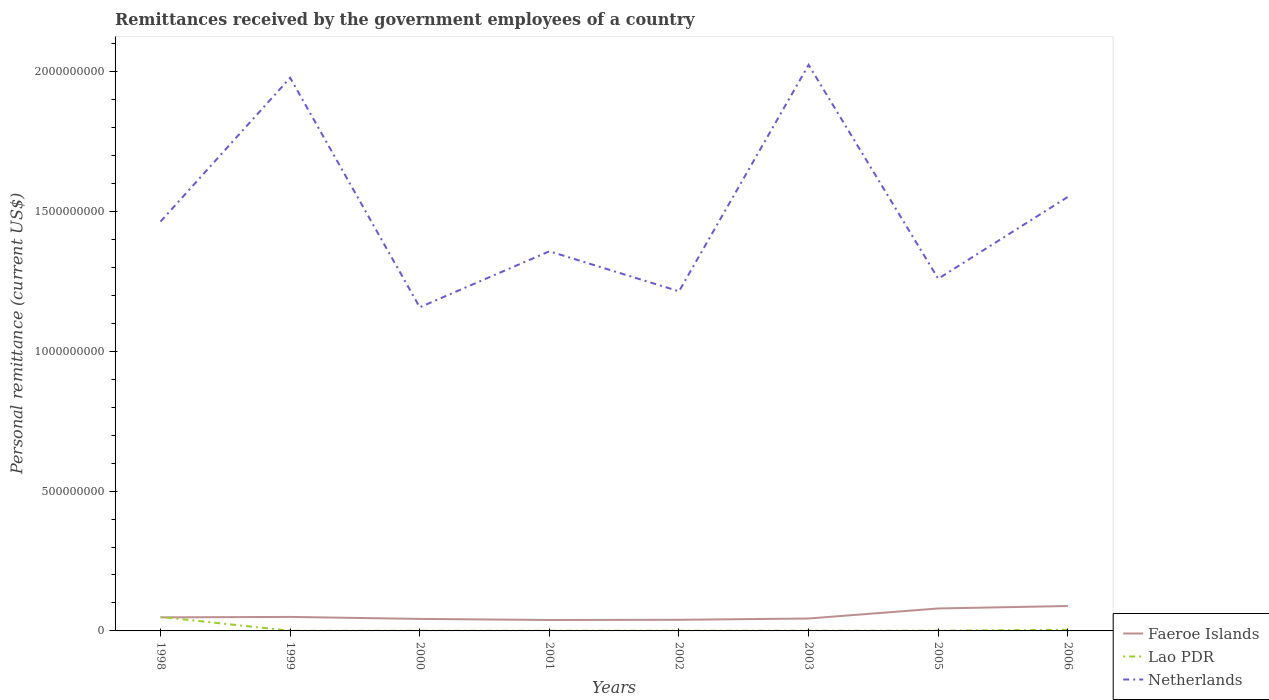How many different coloured lines are there?
Ensure brevity in your answer.  3. Is the number of lines equal to the number of legend labels?
Give a very brief answer. Yes. Across all years, what is the maximum remittances received by the government employees in Faeroe Islands?
Your answer should be compact. 3.90e+07. What is the total remittances received by the government employees in Netherlands in the graph?
Your response must be concise. -6.67e+08. What is the difference between the highest and the second highest remittances received by the government employees in Lao PDR?
Give a very brief answer. 4.94e+07. Is the remittances received by the government employees in Faeroe Islands strictly greater than the remittances received by the government employees in Netherlands over the years?
Offer a very short reply. Yes. Where does the legend appear in the graph?
Give a very brief answer. Bottom right. How many legend labels are there?
Provide a succinct answer. 3. How are the legend labels stacked?
Make the answer very short. Vertical. What is the title of the graph?
Provide a short and direct response. Remittances received by the government employees of a country. Does "Antigua and Barbuda" appear as one of the legend labels in the graph?
Offer a terse response. No. What is the label or title of the X-axis?
Make the answer very short. Years. What is the label or title of the Y-axis?
Your response must be concise. Personal remittance (current US$). What is the Personal remittance (current US$) in Faeroe Islands in 1998?
Your answer should be compact. 4.85e+07. What is the Personal remittance (current US$) in Lao PDR in 1998?
Make the answer very short. 5.00e+07. What is the Personal remittance (current US$) in Netherlands in 1998?
Your answer should be compact. 1.46e+09. What is the Personal remittance (current US$) in Faeroe Islands in 1999?
Give a very brief answer. 5.00e+07. What is the Personal remittance (current US$) of Lao PDR in 1999?
Your answer should be very brief. 6.00e+05. What is the Personal remittance (current US$) of Netherlands in 1999?
Offer a terse response. 1.98e+09. What is the Personal remittance (current US$) of Faeroe Islands in 2000?
Give a very brief answer. 4.30e+07. What is the Personal remittance (current US$) in Lao PDR in 2000?
Provide a succinct answer. 6.60e+05. What is the Personal remittance (current US$) of Netherlands in 2000?
Give a very brief answer. 1.16e+09. What is the Personal remittance (current US$) of Faeroe Islands in 2001?
Give a very brief answer. 3.90e+07. What is the Personal remittance (current US$) of Lao PDR in 2001?
Offer a very short reply. 6.95e+05. What is the Personal remittance (current US$) of Netherlands in 2001?
Offer a terse response. 1.36e+09. What is the Personal remittance (current US$) in Faeroe Islands in 2002?
Your response must be concise. 3.98e+07. What is the Personal remittance (current US$) in Lao PDR in 2002?
Ensure brevity in your answer.  7.29e+05. What is the Personal remittance (current US$) in Netherlands in 2002?
Your response must be concise. 1.21e+09. What is the Personal remittance (current US$) in Faeroe Islands in 2003?
Provide a succinct answer. 4.44e+07. What is the Personal remittance (current US$) in Lao PDR in 2003?
Give a very brief answer. 7.66e+05. What is the Personal remittance (current US$) in Netherlands in 2003?
Give a very brief answer. 2.02e+09. What is the Personal remittance (current US$) of Faeroe Islands in 2005?
Give a very brief answer. 8.03e+07. What is the Personal remittance (current US$) of Lao PDR in 2005?
Offer a very short reply. 8.30e+05. What is the Personal remittance (current US$) of Netherlands in 2005?
Provide a short and direct response. 1.26e+09. What is the Personal remittance (current US$) in Faeroe Islands in 2006?
Ensure brevity in your answer.  8.91e+07. What is the Personal remittance (current US$) of Lao PDR in 2006?
Your answer should be compact. 4.24e+06. What is the Personal remittance (current US$) of Netherlands in 2006?
Your response must be concise. 1.55e+09. Across all years, what is the maximum Personal remittance (current US$) in Faeroe Islands?
Make the answer very short. 8.91e+07. Across all years, what is the maximum Personal remittance (current US$) in Lao PDR?
Your answer should be very brief. 5.00e+07. Across all years, what is the maximum Personal remittance (current US$) in Netherlands?
Keep it short and to the point. 2.02e+09. Across all years, what is the minimum Personal remittance (current US$) of Faeroe Islands?
Your response must be concise. 3.90e+07. Across all years, what is the minimum Personal remittance (current US$) in Lao PDR?
Your answer should be compact. 6.00e+05. Across all years, what is the minimum Personal remittance (current US$) of Netherlands?
Keep it short and to the point. 1.16e+09. What is the total Personal remittance (current US$) of Faeroe Islands in the graph?
Offer a terse response. 4.34e+08. What is the total Personal remittance (current US$) of Lao PDR in the graph?
Your answer should be compact. 5.85e+07. What is the total Personal remittance (current US$) in Netherlands in the graph?
Give a very brief answer. 1.20e+1. What is the difference between the Personal remittance (current US$) of Faeroe Islands in 1998 and that in 1999?
Ensure brevity in your answer.  -1.56e+06. What is the difference between the Personal remittance (current US$) in Lao PDR in 1998 and that in 1999?
Provide a short and direct response. 4.94e+07. What is the difference between the Personal remittance (current US$) of Netherlands in 1998 and that in 1999?
Your answer should be very brief. -5.14e+08. What is the difference between the Personal remittance (current US$) of Faeroe Islands in 1998 and that in 2000?
Provide a succinct answer. 5.51e+06. What is the difference between the Personal remittance (current US$) in Lao PDR in 1998 and that in 2000?
Your response must be concise. 4.93e+07. What is the difference between the Personal remittance (current US$) of Netherlands in 1998 and that in 2000?
Make the answer very short. 3.06e+08. What is the difference between the Personal remittance (current US$) of Faeroe Islands in 1998 and that in 2001?
Provide a succinct answer. 9.44e+06. What is the difference between the Personal remittance (current US$) in Lao PDR in 1998 and that in 2001?
Offer a very short reply. 4.93e+07. What is the difference between the Personal remittance (current US$) in Netherlands in 1998 and that in 2001?
Provide a short and direct response. 1.06e+08. What is the difference between the Personal remittance (current US$) of Faeroe Islands in 1998 and that in 2002?
Give a very brief answer. 8.73e+06. What is the difference between the Personal remittance (current US$) of Lao PDR in 1998 and that in 2002?
Offer a very short reply. 4.93e+07. What is the difference between the Personal remittance (current US$) of Netherlands in 1998 and that in 2002?
Provide a succinct answer. 2.49e+08. What is the difference between the Personal remittance (current US$) in Faeroe Islands in 1998 and that in 2003?
Provide a short and direct response. 4.10e+06. What is the difference between the Personal remittance (current US$) of Lao PDR in 1998 and that in 2003?
Provide a succinct answer. 4.92e+07. What is the difference between the Personal remittance (current US$) in Netherlands in 1998 and that in 2003?
Make the answer very short. -5.60e+08. What is the difference between the Personal remittance (current US$) in Faeroe Islands in 1998 and that in 2005?
Your answer should be very brief. -3.18e+07. What is the difference between the Personal remittance (current US$) of Lao PDR in 1998 and that in 2005?
Your answer should be very brief. 4.92e+07. What is the difference between the Personal remittance (current US$) of Netherlands in 1998 and that in 2005?
Make the answer very short. 2.04e+08. What is the difference between the Personal remittance (current US$) of Faeroe Islands in 1998 and that in 2006?
Your answer should be very brief. -4.06e+07. What is the difference between the Personal remittance (current US$) of Lao PDR in 1998 and that in 2006?
Ensure brevity in your answer.  4.58e+07. What is the difference between the Personal remittance (current US$) of Netherlands in 1998 and that in 2006?
Offer a very short reply. -8.82e+07. What is the difference between the Personal remittance (current US$) in Faeroe Islands in 1999 and that in 2000?
Your answer should be very brief. 7.07e+06. What is the difference between the Personal remittance (current US$) in Lao PDR in 1999 and that in 2000?
Offer a terse response. -6.00e+04. What is the difference between the Personal remittance (current US$) of Netherlands in 1999 and that in 2000?
Provide a succinct answer. 8.21e+08. What is the difference between the Personal remittance (current US$) in Faeroe Islands in 1999 and that in 2001?
Give a very brief answer. 1.10e+07. What is the difference between the Personal remittance (current US$) in Lao PDR in 1999 and that in 2001?
Your response must be concise. -9.46e+04. What is the difference between the Personal remittance (current US$) in Netherlands in 1999 and that in 2001?
Provide a succinct answer. 6.20e+08. What is the difference between the Personal remittance (current US$) of Faeroe Islands in 1999 and that in 2002?
Give a very brief answer. 1.03e+07. What is the difference between the Personal remittance (current US$) in Lao PDR in 1999 and that in 2002?
Offer a terse response. -1.29e+05. What is the difference between the Personal remittance (current US$) in Netherlands in 1999 and that in 2002?
Offer a terse response. 7.63e+08. What is the difference between the Personal remittance (current US$) of Faeroe Islands in 1999 and that in 2003?
Offer a very short reply. 5.66e+06. What is the difference between the Personal remittance (current US$) in Lao PDR in 1999 and that in 2003?
Offer a very short reply. -1.66e+05. What is the difference between the Personal remittance (current US$) of Netherlands in 1999 and that in 2003?
Your response must be concise. -4.61e+07. What is the difference between the Personal remittance (current US$) of Faeroe Islands in 1999 and that in 2005?
Your response must be concise. -3.02e+07. What is the difference between the Personal remittance (current US$) of Lao PDR in 1999 and that in 2005?
Offer a terse response. -2.30e+05. What is the difference between the Personal remittance (current US$) in Netherlands in 1999 and that in 2005?
Keep it short and to the point. 7.19e+08. What is the difference between the Personal remittance (current US$) of Faeroe Islands in 1999 and that in 2006?
Keep it short and to the point. -3.90e+07. What is the difference between the Personal remittance (current US$) of Lao PDR in 1999 and that in 2006?
Offer a terse response. -3.64e+06. What is the difference between the Personal remittance (current US$) in Netherlands in 1999 and that in 2006?
Make the answer very short. 4.26e+08. What is the difference between the Personal remittance (current US$) of Faeroe Islands in 2000 and that in 2001?
Provide a succinct answer. 3.93e+06. What is the difference between the Personal remittance (current US$) of Lao PDR in 2000 and that in 2001?
Offer a very short reply. -3.46e+04. What is the difference between the Personal remittance (current US$) in Netherlands in 2000 and that in 2001?
Provide a short and direct response. -2.00e+08. What is the difference between the Personal remittance (current US$) in Faeroe Islands in 2000 and that in 2002?
Provide a succinct answer. 3.22e+06. What is the difference between the Personal remittance (current US$) in Lao PDR in 2000 and that in 2002?
Give a very brief answer. -6.93e+04. What is the difference between the Personal remittance (current US$) in Netherlands in 2000 and that in 2002?
Give a very brief answer. -5.71e+07. What is the difference between the Personal remittance (current US$) of Faeroe Islands in 2000 and that in 2003?
Keep it short and to the point. -1.41e+06. What is the difference between the Personal remittance (current US$) of Lao PDR in 2000 and that in 2003?
Your response must be concise. -1.06e+05. What is the difference between the Personal remittance (current US$) of Netherlands in 2000 and that in 2003?
Provide a succinct answer. -8.67e+08. What is the difference between the Personal remittance (current US$) of Faeroe Islands in 2000 and that in 2005?
Give a very brief answer. -3.73e+07. What is the difference between the Personal remittance (current US$) in Lao PDR in 2000 and that in 2005?
Provide a succinct answer. -1.70e+05. What is the difference between the Personal remittance (current US$) in Netherlands in 2000 and that in 2005?
Offer a very short reply. -1.02e+08. What is the difference between the Personal remittance (current US$) in Faeroe Islands in 2000 and that in 2006?
Give a very brief answer. -4.61e+07. What is the difference between the Personal remittance (current US$) in Lao PDR in 2000 and that in 2006?
Provide a succinct answer. -3.58e+06. What is the difference between the Personal remittance (current US$) of Netherlands in 2000 and that in 2006?
Offer a very short reply. -3.95e+08. What is the difference between the Personal remittance (current US$) of Faeroe Islands in 2001 and that in 2002?
Give a very brief answer. -7.10e+05. What is the difference between the Personal remittance (current US$) in Lao PDR in 2001 and that in 2002?
Provide a succinct answer. -3.47e+04. What is the difference between the Personal remittance (current US$) in Netherlands in 2001 and that in 2002?
Your answer should be compact. 1.43e+08. What is the difference between the Personal remittance (current US$) of Faeroe Islands in 2001 and that in 2003?
Provide a short and direct response. -5.34e+06. What is the difference between the Personal remittance (current US$) in Lao PDR in 2001 and that in 2003?
Your answer should be compact. -7.12e+04. What is the difference between the Personal remittance (current US$) of Netherlands in 2001 and that in 2003?
Make the answer very short. -6.67e+08. What is the difference between the Personal remittance (current US$) of Faeroe Islands in 2001 and that in 2005?
Your answer should be compact. -4.12e+07. What is the difference between the Personal remittance (current US$) in Lao PDR in 2001 and that in 2005?
Offer a terse response. -1.35e+05. What is the difference between the Personal remittance (current US$) in Netherlands in 2001 and that in 2005?
Keep it short and to the point. 9.80e+07. What is the difference between the Personal remittance (current US$) of Faeroe Islands in 2001 and that in 2006?
Your answer should be compact. -5.00e+07. What is the difference between the Personal remittance (current US$) of Lao PDR in 2001 and that in 2006?
Provide a short and direct response. -3.54e+06. What is the difference between the Personal remittance (current US$) in Netherlands in 2001 and that in 2006?
Offer a terse response. -1.95e+08. What is the difference between the Personal remittance (current US$) in Faeroe Islands in 2002 and that in 2003?
Keep it short and to the point. -4.63e+06. What is the difference between the Personal remittance (current US$) in Lao PDR in 2002 and that in 2003?
Give a very brief answer. -3.65e+04. What is the difference between the Personal remittance (current US$) in Netherlands in 2002 and that in 2003?
Provide a succinct answer. -8.10e+08. What is the difference between the Personal remittance (current US$) in Faeroe Islands in 2002 and that in 2005?
Your response must be concise. -4.05e+07. What is the difference between the Personal remittance (current US$) of Lao PDR in 2002 and that in 2005?
Your answer should be very brief. -1.01e+05. What is the difference between the Personal remittance (current US$) in Netherlands in 2002 and that in 2005?
Provide a short and direct response. -4.49e+07. What is the difference between the Personal remittance (current US$) of Faeroe Islands in 2002 and that in 2006?
Your response must be concise. -4.93e+07. What is the difference between the Personal remittance (current US$) in Lao PDR in 2002 and that in 2006?
Keep it short and to the point. -3.51e+06. What is the difference between the Personal remittance (current US$) of Netherlands in 2002 and that in 2006?
Provide a short and direct response. -3.38e+08. What is the difference between the Personal remittance (current US$) of Faeroe Islands in 2003 and that in 2005?
Ensure brevity in your answer.  -3.59e+07. What is the difference between the Personal remittance (current US$) in Lao PDR in 2003 and that in 2005?
Provide a succinct answer. -6.42e+04. What is the difference between the Personal remittance (current US$) of Netherlands in 2003 and that in 2005?
Your response must be concise. 7.65e+08. What is the difference between the Personal remittance (current US$) in Faeroe Islands in 2003 and that in 2006?
Your answer should be very brief. -4.47e+07. What is the difference between the Personal remittance (current US$) in Lao PDR in 2003 and that in 2006?
Keep it short and to the point. -3.47e+06. What is the difference between the Personal remittance (current US$) in Netherlands in 2003 and that in 2006?
Provide a succinct answer. 4.72e+08. What is the difference between the Personal remittance (current US$) of Faeroe Islands in 2005 and that in 2006?
Give a very brief answer. -8.77e+06. What is the difference between the Personal remittance (current US$) of Lao PDR in 2005 and that in 2006?
Give a very brief answer. -3.41e+06. What is the difference between the Personal remittance (current US$) of Netherlands in 2005 and that in 2006?
Provide a succinct answer. -2.93e+08. What is the difference between the Personal remittance (current US$) in Faeroe Islands in 1998 and the Personal remittance (current US$) in Lao PDR in 1999?
Provide a short and direct response. 4.79e+07. What is the difference between the Personal remittance (current US$) in Faeroe Islands in 1998 and the Personal remittance (current US$) in Netherlands in 1999?
Make the answer very short. -1.93e+09. What is the difference between the Personal remittance (current US$) of Lao PDR in 1998 and the Personal remittance (current US$) of Netherlands in 1999?
Your answer should be compact. -1.93e+09. What is the difference between the Personal remittance (current US$) in Faeroe Islands in 1998 and the Personal remittance (current US$) in Lao PDR in 2000?
Provide a short and direct response. 4.78e+07. What is the difference between the Personal remittance (current US$) in Faeroe Islands in 1998 and the Personal remittance (current US$) in Netherlands in 2000?
Give a very brief answer. -1.11e+09. What is the difference between the Personal remittance (current US$) of Lao PDR in 1998 and the Personal remittance (current US$) of Netherlands in 2000?
Offer a very short reply. -1.11e+09. What is the difference between the Personal remittance (current US$) in Faeroe Islands in 1998 and the Personal remittance (current US$) in Lao PDR in 2001?
Offer a terse response. 4.78e+07. What is the difference between the Personal remittance (current US$) in Faeroe Islands in 1998 and the Personal remittance (current US$) in Netherlands in 2001?
Offer a terse response. -1.31e+09. What is the difference between the Personal remittance (current US$) in Lao PDR in 1998 and the Personal remittance (current US$) in Netherlands in 2001?
Your answer should be compact. -1.31e+09. What is the difference between the Personal remittance (current US$) of Faeroe Islands in 1998 and the Personal remittance (current US$) of Lao PDR in 2002?
Offer a very short reply. 4.78e+07. What is the difference between the Personal remittance (current US$) in Faeroe Islands in 1998 and the Personal remittance (current US$) in Netherlands in 2002?
Provide a succinct answer. -1.17e+09. What is the difference between the Personal remittance (current US$) of Lao PDR in 1998 and the Personal remittance (current US$) of Netherlands in 2002?
Your response must be concise. -1.16e+09. What is the difference between the Personal remittance (current US$) of Faeroe Islands in 1998 and the Personal remittance (current US$) of Lao PDR in 2003?
Your answer should be very brief. 4.77e+07. What is the difference between the Personal remittance (current US$) of Faeroe Islands in 1998 and the Personal remittance (current US$) of Netherlands in 2003?
Offer a terse response. -1.98e+09. What is the difference between the Personal remittance (current US$) of Lao PDR in 1998 and the Personal remittance (current US$) of Netherlands in 2003?
Your response must be concise. -1.97e+09. What is the difference between the Personal remittance (current US$) of Faeroe Islands in 1998 and the Personal remittance (current US$) of Lao PDR in 2005?
Offer a very short reply. 4.76e+07. What is the difference between the Personal remittance (current US$) in Faeroe Islands in 1998 and the Personal remittance (current US$) in Netherlands in 2005?
Your answer should be very brief. -1.21e+09. What is the difference between the Personal remittance (current US$) of Lao PDR in 1998 and the Personal remittance (current US$) of Netherlands in 2005?
Your answer should be compact. -1.21e+09. What is the difference between the Personal remittance (current US$) of Faeroe Islands in 1998 and the Personal remittance (current US$) of Lao PDR in 2006?
Your answer should be very brief. 4.42e+07. What is the difference between the Personal remittance (current US$) in Faeroe Islands in 1998 and the Personal remittance (current US$) in Netherlands in 2006?
Make the answer very short. -1.50e+09. What is the difference between the Personal remittance (current US$) of Lao PDR in 1998 and the Personal remittance (current US$) of Netherlands in 2006?
Offer a terse response. -1.50e+09. What is the difference between the Personal remittance (current US$) of Faeroe Islands in 1999 and the Personal remittance (current US$) of Lao PDR in 2000?
Keep it short and to the point. 4.94e+07. What is the difference between the Personal remittance (current US$) in Faeroe Islands in 1999 and the Personal remittance (current US$) in Netherlands in 2000?
Your answer should be compact. -1.11e+09. What is the difference between the Personal remittance (current US$) in Lao PDR in 1999 and the Personal remittance (current US$) in Netherlands in 2000?
Give a very brief answer. -1.16e+09. What is the difference between the Personal remittance (current US$) in Faeroe Islands in 1999 and the Personal remittance (current US$) in Lao PDR in 2001?
Your answer should be very brief. 4.93e+07. What is the difference between the Personal remittance (current US$) of Faeroe Islands in 1999 and the Personal remittance (current US$) of Netherlands in 2001?
Keep it short and to the point. -1.31e+09. What is the difference between the Personal remittance (current US$) in Lao PDR in 1999 and the Personal remittance (current US$) in Netherlands in 2001?
Your answer should be very brief. -1.36e+09. What is the difference between the Personal remittance (current US$) of Faeroe Islands in 1999 and the Personal remittance (current US$) of Lao PDR in 2002?
Keep it short and to the point. 4.93e+07. What is the difference between the Personal remittance (current US$) in Faeroe Islands in 1999 and the Personal remittance (current US$) in Netherlands in 2002?
Ensure brevity in your answer.  -1.16e+09. What is the difference between the Personal remittance (current US$) in Lao PDR in 1999 and the Personal remittance (current US$) in Netherlands in 2002?
Keep it short and to the point. -1.21e+09. What is the difference between the Personal remittance (current US$) of Faeroe Islands in 1999 and the Personal remittance (current US$) of Lao PDR in 2003?
Make the answer very short. 4.93e+07. What is the difference between the Personal remittance (current US$) of Faeroe Islands in 1999 and the Personal remittance (current US$) of Netherlands in 2003?
Your answer should be compact. -1.97e+09. What is the difference between the Personal remittance (current US$) of Lao PDR in 1999 and the Personal remittance (current US$) of Netherlands in 2003?
Your answer should be very brief. -2.02e+09. What is the difference between the Personal remittance (current US$) of Faeroe Islands in 1999 and the Personal remittance (current US$) of Lao PDR in 2005?
Ensure brevity in your answer.  4.92e+07. What is the difference between the Personal remittance (current US$) of Faeroe Islands in 1999 and the Personal remittance (current US$) of Netherlands in 2005?
Offer a terse response. -1.21e+09. What is the difference between the Personal remittance (current US$) of Lao PDR in 1999 and the Personal remittance (current US$) of Netherlands in 2005?
Your answer should be compact. -1.26e+09. What is the difference between the Personal remittance (current US$) in Faeroe Islands in 1999 and the Personal remittance (current US$) in Lao PDR in 2006?
Give a very brief answer. 4.58e+07. What is the difference between the Personal remittance (current US$) in Faeroe Islands in 1999 and the Personal remittance (current US$) in Netherlands in 2006?
Give a very brief answer. -1.50e+09. What is the difference between the Personal remittance (current US$) in Lao PDR in 1999 and the Personal remittance (current US$) in Netherlands in 2006?
Make the answer very short. -1.55e+09. What is the difference between the Personal remittance (current US$) in Faeroe Islands in 2000 and the Personal remittance (current US$) in Lao PDR in 2001?
Ensure brevity in your answer.  4.23e+07. What is the difference between the Personal remittance (current US$) in Faeroe Islands in 2000 and the Personal remittance (current US$) in Netherlands in 2001?
Offer a very short reply. -1.31e+09. What is the difference between the Personal remittance (current US$) of Lao PDR in 2000 and the Personal remittance (current US$) of Netherlands in 2001?
Your answer should be very brief. -1.36e+09. What is the difference between the Personal remittance (current US$) of Faeroe Islands in 2000 and the Personal remittance (current US$) of Lao PDR in 2002?
Offer a very short reply. 4.22e+07. What is the difference between the Personal remittance (current US$) in Faeroe Islands in 2000 and the Personal remittance (current US$) in Netherlands in 2002?
Provide a short and direct response. -1.17e+09. What is the difference between the Personal remittance (current US$) in Lao PDR in 2000 and the Personal remittance (current US$) in Netherlands in 2002?
Your answer should be very brief. -1.21e+09. What is the difference between the Personal remittance (current US$) in Faeroe Islands in 2000 and the Personal remittance (current US$) in Lao PDR in 2003?
Offer a terse response. 4.22e+07. What is the difference between the Personal remittance (current US$) of Faeroe Islands in 2000 and the Personal remittance (current US$) of Netherlands in 2003?
Offer a terse response. -1.98e+09. What is the difference between the Personal remittance (current US$) in Lao PDR in 2000 and the Personal remittance (current US$) in Netherlands in 2003?
Give a very brief answer. -2.02e+09. What is the difference between the Personal remittance (current US$) of Faeroe Islands in 2000 and the Personal remittance (current US$) of Lao PDR in 2005?
Your answer should be very brief. 4.21e+07. What is the difference between the Personal remittance (current US$) in Faeroe Islands in 2000 and the Personal remittance (current US$) in Netherlands in 2005?
Provide a succinct answer. -1.22e+09. What is the difference between the Personal remittance (current US$) in Lao PDR in 2000 and the Personal remittance (current US$) in Netherlands in 2005?
Provide a succinct answer. -1.26e+09. What is the difference between the Personal remittance (current US$) in Faeroe Islands in 2000 and the Personal remittance (current US$) in Lao PDR in 2006?
Offer a very short reply. 3.87e+07. What is the difference between the Personal remittance (current US$) in Faeroe Islands in 2000 and the Personal remittance (current US$) in Netherlands in 2006?
Your answer should be compact. -1.51e+09. What is the difference between the Personal remittance (current US$) in Lao PDR in 2000 and the Personal remittance (current US$) in Netherlands in 2006?
Your answer should be compact. -1.55e+09. What is the difference between the Personal remittance (current US$) of Faeroe Islands in 2001 and the Personal remittance (current US$) of Lao PDR in 2002?
Provide a short and direct response. 3.83e+07. What is the difference between the Personal remittance (current US$) in Faeroe Islands in 2001 and the Personal remittance (current US$) in Netherlands in 2002?
Give a very brief answer. -1.18e+09. What is the difference between the Personal remittance (current US$) in Lao PDR in 2001 and the Personal remittance (current US$) in Netherlands in 2002?
Give a very brief answer. -1.21e+09. What is the difference between the Personal remittance (current US$) of Faeroe Islands in 2001 and the Personal remittance (current US$) of Lao PDR in 2003?
Provide a short and direct response. 3.83e+07. What is the difference between the Personal remittance (current US$) of Faeroe Islands in 2001 and the Personal remittance (current US$) of Netherlands in 2003?
Ensure brevity in your answer.  -1.98e+09. What is the difference between the Personal remittance (current US$) in Lao PDR in 2001 and the Personal remittance (current US$) in Netherlands in 2003?
Your response must be concise. -2.02e+09. What is the difference between the Personal remittance (current US$) in Faeroe Islands in 2001 and the Personal remittance (current US$) in Lao PDR in 2005?
Your response must be concise. 3.82e+07. What is the difference between the Personal remittance (current US$) in Faeroe Islands in 2001 and the Personal remittance (current US$) in Netherlands in 2005?
Provide a short and direct response. -1.22e+09. What is the difference between the Personal remittance (current US$) of Lao PDR in 2001 and the Personal remittance (current US$) of Netherlands in 2005?
Ensure brevity in your answer.  -1.26e+09. What is the difference between the Personal remittance (current US$) of Faeroe Islands in 2001 and the Personal remittance (current US$) of Lao PDR in 2006?
Give a very brief answer. 3.48e+07. What is the difference between the Personal remittance (current US$) of Faeroe Islands in 2001 and the Personal remittance (current US$) of Netherlands in 2006?
Provide a succinct answer. -1.51e+09. What is the difference between the Personal remittance (current US$) of Lao PDR in 2001 and the Personal remittance (current US$) of Netherlands in 2006?
Provide a succinct answer. -1.55e+09. What is the difference between the Personal remittance (current US$) in Faeroe Islands in 2002 and the Personal remittance (current US$) in Lao PDR in 2003?
Give a very brief answer. 3.90e+07. What is the difference between the Personal remittance (current US$) in Faeroe Islands in 2002 and the Personal remittance (current US$) in Netherlands in 2003?
Make the answer very short. -1.98e+09. What is the difference between the Personal remittance (current US$) in Lao PDR in 2002 and the Personal remittance (current US$) in Netherlands in 2003?
Your response must be concise. -2.02e+09. What is the difference between the Personal remittance (current US$) of Faeroe Islands in 2002 and the Personal remittance (current US$) of Lao PDR in 2005?
Offer a very short reply. 3.89e+07. What is the difference between the Personal remittance (current US$) of Faeroe Islands in 2002 and the Personal remittance (current US$) of Netherlands in 2005?
Give a very brief answer. -1.22e+09. What is the difference between the Personal remittance (current US$) in Lao PDR in 2002 and the Personal remittance (current US$) in Netherlands in 2005?
Your response must be concise. -1.26e+09. What is the difference between the Personal remittance (current US$) of Faeroe Islands in 2002 and the Personal remittance (current US$) of Lao PDR in 2006?
Your answer should be very brief. 3.55e+07. What is the difference between the Personal remittance (current US$) of Faeroe Islands in 2002 and the Personal remittance (current US$) of Netherlands in 2006?
Keep it short and to the point. -1.51e+09. What is the difference between the Personal remittance (current US$) of Lao PDR in 2002 and the Personal remittance (current US$) of Netherlands in 2006?
Your answer should be compact. -1.55e+09. What is the difference between the Personal remittance (current US$) of Faeroe Islands in 2003 and the Personal remittance (current US$) of Lao PDR in 2005?
Ensure brevity in your answer.  4.36e+07. What is the difference between the Personal remittance (current US$) in Faeroe Islands in 2003 and the Personal remittance (current US$) in Netherlands in 2005?
Give a very brief answer. -1.21e+09. What is the difference between the Personal remittance (current US$) of Lao PDR in 2003 and the Personal remittance (current US$) of Netherlands in 2005?
Provide a short and direct response. -1.26e+09. What is the difference between the Personal remittance (current US$) in Faeroe Islands in 2003 and the Personal remittance (current US$) in Lao PDR in 2006?
Provide a short and direct response. 4.01e+07. What is the difference between the Personal remittance (current US$) of Faeroe Islands in 2003 and the Personal remittance (current US$) of Netherlands in 2006?
Keep it short and to the point. -1.51e+09. What is the difference between the Personal remittance (current US$) of Lao PDR in 2003 and the Personal remittance (current US$) of Netherlands in 2006?
Ensure brevity in your answer.  -1.55e+09. What is the difference between the Personal remittance (current US$) of Faeroe Islands in 2005 and the Personal remittance (current US$) of Lao PDR in 2006?
Provide a succinct answer. 7.60e+07. What is the difference between the Personal remittance (current US$) in Faeroe Islands in 2005 and the Personal remittance (current US$) in Netherlands in 2006?
Your response must be concise. -1.47e+09. What is the difference between the Personal remittance (current US$) of Lao PDR in 2005 and the Personal remittance (current US$) of Netherlands in 2006?
Your answer should be compact. -1.55e+09. What is the average Personal remittance (current US$) in Faeroe Islands per year?
Ensure brevity in your answer.  5.42e+07. What is the average Personal remittance (current US$) in Lao PDR per year?
Your answer should be very brief. 7.31e+06. What is the average Personal remittance (current US$) of Netherlands per year?
Provide a short and direct response. 1.50e+09. In the year 1998, what is the difference between the Personal remittance (current US$) in Faeroe Islands and Personal remittance (current US$) in Lao PDR?
Give a very brief answer. -1.52e+06. In the year 1998, what is the difference between the Personal remittance (current US$) in Faeroe Islands and Personal remittance (current US$) in Netherlands?
Provide a short and direct response. -1.42e+09. In the year 1998, what is the difference between the Personal remittance (current US$) of Lao PDR and Personal remittance (current US$) of Netherlands?
Ensure brevity in your answer.  -1.41e+09. In the year 1999, what is the difference between the Personal remittance (current US$) in Faeroe Islands and Personal remittance (current US$) in Lao PDR?
Offer a very short reply. 4.94e+07. In the year 1999, what is the difference between the Personal remittance (current US$) of Faeroe Islands and Personal remittance (current US$) of Netherlands?
Keep it short and to the point. -1.93e+09. In the year 1999, what is the difference between the Personal remittance (current US$) in Lao PDR and Personal remittance (current US$) in Netherlands?
Your answer should be very brief. -1.98e+09. In the year 2000, what is the difference between the Personal remittance (current US$) in Faeroe Islands and Personal remittance (current US$) in Lao PDR?
Offer a terse response. 4.23e+07. In the year 2000, what is the difference between the Personal remittance (current US$) of Faeroe Islands and Personal remittance (current US$) of Netherlands?
Provide a succinct answer. -1.11e+09. In the year 2000, what is the difference between the Personal remittance (current US$) in Lao PDR and Personal remittance (current US$) in Netherlands?
Provide a short and direct response. -1.16e+09. In the year 2001, what is the difference between the Personal remittance (current US$) in Faeroe Islands and Personal remittance (current US$) in Lao PDR?
Give a very brief answer. 3.83e+07. In the year 2001, what is the difference between the Personal remittance (current US$) in Faeroe Islands and Personal remittance (current US$) in Netherlands?
Offer a very short reply. -1.32e+09. In the year 2001, what is the difference between the Personal remittance (current US$) of Lao PDR and Personal remittance (current US$) of Netherlands?
Keep it short and to the point. -1.36e+09. In the year 2002, what is the difference between the Personal remittance (current US$) of Faeroe Islands and Personal remittance (current US$) of Lao PDR?
Your answer should be compact. 3.90e+07. In the year 2002, what is the difference between the Personal remittance (current US$) in Faeroe Islands and Personal remittance (current US$) in Netherlands?
Provide a short and direct response. -1.17e+09. In the year 2002, what is the difference between the Personal remittance (current US$) in Lao PDR and Personal remittance (current US$) in Netherlands?
Make the answer very short. -1.21e+09. In the year 2003, what is the difference between the Personal remittance (current US$) of Faeroe Islands and Personal remittance (current US$) of Lao PDR?
Your answer should be compact. 4.36e+07. In the year 2003, what is the difference between the Personal remittance (current US$) in Faeroe Islands and Personal remittance (current US$) in Netherlands?
Your answer should be very brief. -1.98e+09. In the year 2003, what is the difference between the Personal remittance (current US$) of Lao PDR and Personal remittance (current US$) of Netherlands?
Make the answer very short. -2.02e+09. In the year 2005, what is the difference between the Personal remittance (current US$) in Faeroe Islands and Personal remittance (current US$) in Lao PDR?
Keep it short and to the point. 7.95e+07. In the year 2005, what is the difference between the Personal remittance (current US$) of Faeroe Islands and Personal remittance (current US$) of Netherlands?
Provide a short and direct response. -1.18e+09. In the year 2005, what is the difference between the Personal remittance (current US$) of Lao PDR and Personal remittance (current US$) of Netherlands?
Give a very brief answer. -1.26e+09. In the year 2006, what is the difference between the Personal remittance (current US$) of Faeroe Islands and Personal remittance (current US$) of Lao PDR?
Keep it short and to the point. 8.48e+07. In the year 2006, what is the difference between the Personal remittance (current US$) of Faeroe Islands and Personal remittance (current US$) of Netherlands?
Ensure brevity in your answer.  -1.46e+09. In the year 2006, what is the difference between the Personal remittance (current US$) in Lao PDR and Personal remittance (current US$) in Netherlands?
Keep it short and to the point. -1.55e+09. What is the ratio of the Personal remittance (current US$) of Faeroe Islands in 1998 to that in 1999?
Provide a short and direct response. 0.97. What is the ratio of the Personal remittance (current US$) in Lao PDR in 1998 to that in 1999?
Make the answer very short. 83.33. What is the ratio of the Personal remittance (current US$) of Netherlands in 1998 to that in 1999?
Provide a short and direct response. 0.74. What is the ratio of the Personal remittance (current US$) of Faeroe Islands in 1998 to that in 2000?
Provide a succinct answer. 1.13. What is the ratio of the Personal remittance (current US$) in Lao PDR in 1998 to that in 2000?
Make the answer very short. 75.76. What is the ratio of the Personal remittance (current US$) of Netherlands in 1998 to that in 2000?
Make the answer very short. 1.26. What is the ratio of the Personal remittance (current US$) of Faeroe Islands in 1998 to that in 2001?
Offer a very short reply. 1.24. What is the ratio of the Personal remittance (current US$) in Lao PDR in 1998 to that in 2001?
Keep it short and to the point. 71.99. What is the ratio of the Personal remittance (current US$) of Netherlands in 1998 to that in 2001?
Your answer should be compact. 1.08. What is the ratio of the Personal remittance (current US$) of Faeroe Islands in 1998 to that in 2002?
Make the answer very short. 1.22. What is the ratio of the Personal remittance (current US$) of Lao PDR in 1998 to that in 2002?
Keep it short and to the point. 68.56. What is the ratio of the Personal remittance (current US$) in Netherlands in 1998 to that in 2002?
Offer a very short reply. 1.21. What is the ratio of the Personal remittance (current US$) in Faeroe Islands in 1998 to that in 2003?
Your answer should be compact. 1.09. What is the ratio of the Personal remittance (current US$) in Lao PDR in 1998 to that in 2003?
Give a very brief answer. 65.29. What is the ratio of the Personal remittance (current US$) in Netherlands in 1998 to that in 2003?
Make the answer very short. 0.72. What is the ratio of the Personal remittance (current US$) of Faeroe Islands in 1998 to that in 2005?
Provide a succinct answer. 0.6. What is the ratio of the Personal remittance (current US$) of Lao PDR in 1998 to that in 2005?
Your answer should be compact. 60.24. What is the ratio of the Personal remittance (current US$) of Netherlands in 1998 to that in 2005?
Provide a short and direct response. 1.16. What is the ratio of the Personal remittance (current US$) in Faeroe Islands in 1998 to that in 2006?
Provide a short and direct response. 0.54. What is the ratio of the Personal remittance (current US$) in Lao PDR in 1998 to that in 2006?
Make the answer very short. 11.8. What is the ratio of the Personal remittance (current US$) in Netherlands in 1998 to that in 2006?
Your answer should be very brief. 0.94. What is the ratio of the Personal remittance (current US$) of Faeroe Islands in 1999 to that in 2000?
Your answer should be very brief. 1.16. What is the ratio of the Personal remittance (current US$) of Lao PDR in 1999 to that in 2000?
Offer a very short reply. 0.91. What is the ratio of the Personal remittance (current US$) of Netherlands in 1999 to that in 2000?
Your response must be concise. 1.71. What is the ratio of the Personal remittance (current US$) in Faeroe Islands in 1999 to that in 2001?
Ensure brevity in your answer.  1.28. What is the ratio of the Personal remittance (current US$) of Lao PDR in 1999 to that in 2001?
Provide a succinct answer. 0.86. What is the ratio of the Personal remittance (current US$) of Netherlands in 1999 to that in 2001?
Your answer should be very brief. 1.46. What is the ratio of the Personal remittance (current US$) of Faeroe Islands in 1999 to that in 2002?
Offer a very short reply. 1.26. What is the ratio of the Personal remittance (current US$) of Lao PDR in 1999 to that in 2002?
Ensure brevity in your answer.  0.82. What is the ratio of the Personal remittance (current US$) of Netherlands in 1999 to that in 2002?
Provide a succinct answer. 1.63. What is the ratio of the Personal remittance (current US$) of Faeroe Islands in 1999 to that in 2003?
Make the answer very short. 1.13. What is the ratio of the Personal remittance (current US$) of Lao PDR in 1999 to that in 2003?
Your answer should be very brief. 0.78. What is the ratio of the Personal remittance (current US$) of Netherlands in 1999 to that in 2003?
Ensure brevity in your answer.  0.98. What is the ratio of the Personal remittance (current US$) of Faeroe Islands in 1999 to that in 2005?
Keep it short and to the point. 0.62. What is the ratio of the Personal remittance (current US$) in Lao PDR in 1999 to that in 2005?
Provide a succinct answer. 0.72. What is the ratio of the Personal remittance (current US$) in Netherlands in 1999 to that in 2005?
Your answer should be very brief. 1.57. What is the ratio of the Personal remittance (current US$) of Faeroe Islands in 1999 to that in 2006?
Make the answer very short. 0.56. What is the ratio of the Personal remittance (current US$) in Lao PDR in 1999 to that in 2006?
Offer a terse response. 0.14. What is the ratio of the Personal remittance (current US$) in Netherlands in 1999 to that in 2006?
Offer a very short reply. 1.27. What is the ratio of the Personal remittance (current US$) in Faeroe Islands in 2000 to that in 2001?
Your answer should be compact. 1.1. What is the ratio of the Personal remittance (current US$) in Lao PDR in 2000 to that in 2001?
Make the answer very short. 0.95. What is the ratio of the Personal remittance (current US$) of Netherlands in 2000 to that in 2001?
Ensure brevity in your answer.  0.85. What is the ratio of the Personal remittance (current US$) of Faeroe Islands in 2000 to that in 2002?
Your answer should be very brief. 1.08. What is the ratio of the Personal remittance (current US$) in Lao PDR in 2000 to that in 2002?
Your answer should be very brief. 0.91. What is the ratio of the Personal remittance (current US$) of Netherlands in 2000 to that in 2002?
Ensure brevity in your answer.  0.95. What is the ratio of the Personal remittance (current US$) in Faeroe Islands in 2000 to that in 2003?
Your answer should be compact. 0.97. What is the ratio of the Personal remittance (current US$) in Lao PDR in 2000 to that in 2003?
Your response must be concise. 0.86. What is the ratio of the Personal remittance (current US$) in Netherlands in 2000 to that in 2003?
Make the answer very short. 0.57. What is the ratio of the Personal remittance (current US$) in Faeroe Islands in 2000 to that in 2005?
Keep it short and to the point. 0.54. What is the ratio of the Personal remittance (current US$) of Lao PDR in 2000 to that in 2005?
Your answer should be compact. 0.8. What is the ratio of the Personal remittance (current US$) of Netherlands in 2000 to that in 2005?
Ensure brevity in your answer.  0.92. What is the ratio of the Personal remittance (current US$) of Faeroe Islands in 2000 to that in 2006?
Your answer should be very brief. 0.48. What is the ratio of the Personal remittance (current US$) of Lao PDR in 2000 to that in 2006?
Your answer should be compact. 0.16. What is the ratio of the Personal remittance (current US$) of Netherlands in 2000 to that in 2006?
Keep it short and to the point. 0.75. What is the ratio of the Personal remittance (current US$) in Faeroe Islands in 2001 to that in 2002?
Ensure brevity in your answer.  0.98. What is the ratio of the Personal remittance (current US$) in Netherlands in 2001 to that in 2002?
Your answer should be compact. 1.12. What is the ratio of the Personal remittance (current US$) in Faeroe Islands in 2001 to that in 2003?
Your answer should be compact. 0.88. What is the ratio of the Personal remittance (current US$) of Lao PDR in 2001 to that in 2003?
Your answer should be very brief. 0.91. What is the ratio of the Personal remittance (current US$) of Netherlands in 2001 to that in 2003?
Provide a succinct answer. 0.67. What is the ratio of the Personal remittance (current US$) in Faeroe Islands in 2001 to that in 2005?
Provide a short and direct response. 0.49. What is the ratio of the Personal remittance (current US$) in Lao PDR in 2001 to that in 2005?
Offer a very short reply. 0.84. What is the ratio of the Personal remittance (current US$) of Netherlands in 2001 to that in 2005?
Your response must be concise. 1.08. What is the ratio of the Personal remittance (current US$) of Faeroe Islands in 2001 to that in 2006?
Give a very brief answer. 0.44. What is the ratio of the Personal remittance (current US$) of Lao PDR in 2001 to that in 2006?
Provide a succinct answer. 0.16. What is the ratio of the Personal remittance (current US$) in Netherlands in 2001 to that in 2006?
Make the answer very short. 0.87. What is the ratio of the Personal remittance (current US$) of Faeroe Islands in 2002 to that in 2003?
Make the answer very short. 0.9. What is the ratio of the Personal remittance (current US$) of Faeroe Islands in 2002 to that in 2005?
Your answer should be compact. 0.5. What is the ratio of the Personal remittance (current US$) in Lao PDR in 2002 to that in 2005?
Provide a short and direct response. 0.88. What is the ratio of the Personal remittance (current US$) of Netherlands in 2002 to that in 2005?
Ensure brevity in your answer.  0.96. What is the ratio of the Personal remittance (current US$) in Faeroe Islands in 2002 to that in 2006?
Your answer should be compact. 0.45. What is the ratio of the Personal remittance (current US$) in Lao PDR in 2002 to that in 2006?
Ensure brevity in your answer.  0.17. What is the ratio of the Personal remittance (current US$) of Netherlands in 2002 to that in 2006?
Give a very brief answer. 0.78. What is the ratio of the Personal remittance (current US$) of Faeroe Islands in 2003 to that in 2005?
Give a very brief answer. 0.55. What is the ratio of the Personal remittance (current US$) of Lao PDR in 2003 to that in 2005?
Your answer should be compact. 0.92. What is the ratio of the Personal remittance (current US$) in Netherlands in 2003 to that in 2005?
Your answer should be compact. 1.61. What is the ratio of the Personal remittance (current US$) of Faeroe Islands in 2003 to that in 2006?
Ensure brevity in your answer.  0.5. What is the ratio of the Personal remittance (current US$) in Lao PDR in 2003 to that in 2006?
Your response must be concise. 0.18. What is the ratio of the Personal remittance (current US$) in Netherlands in 2003 to that in 2006?
Give a very brief answer. 1.3. What is the ratio of the Personal remittance (current US$) of Faeroe Islands in 2005 to that in 2006?
Keep it short and to the point. 0.9. What is the ratio of the Personal remittance (current US$) in Lao PDR in 2005 to that in 2006?
Offer a terse response. 0.2. What is the ratio of the Personal remittance (current US$) in Netherlands in 2005 to that in 2006?
Provide a short and direct response. 0.81. What is the difference between the highest and the second highest Personal remittance (current US$) of Faeroe Islands?
Your answer should be very brief. 8.77e+06. What is the difference between the highest and the second highest Personal remittance (current US$) of Lao PDR?
Provide a succinct answer. 4.58e+07. What is the difference between the highest and the second highest Personal remittance (current US$) of Netherlands?
Give a very brief answer. 4.61e+07. What is the difference between the highest and the lowest Personal remittance (current US$) in Faeroe Islands?
Make the answer very short. 5.00e+07. What is the difference between the highest and the lowest Personal remittance (current US$) in Lao PDR?
Keep it short and to the point. 4.94e+07. What is the difference between the highest and the lowest Personal remittance (current US$) of Netherlands?
Give a very brief answer. 8.67e+08. 